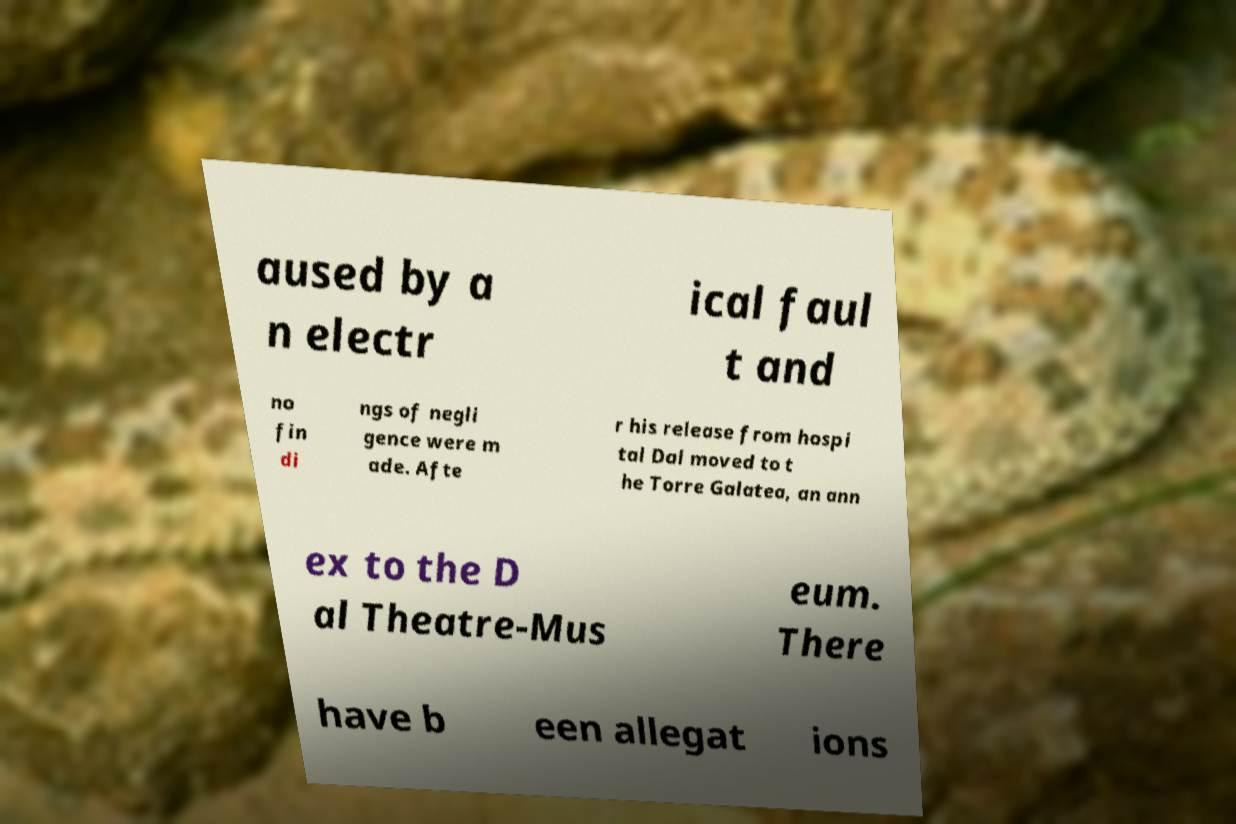Can you read and provide the text displayed in the image?This photo seems to have some interesting text. Can you extract and type it out for me? aused by a n electr ical faul t and no fin di ngs of negli gence were m ade. Afte r his release from hospi tal Dal moved to t he Torre Galatea, an ann ex to the D al Theatre-Mus eum. There have b een allegat ions 